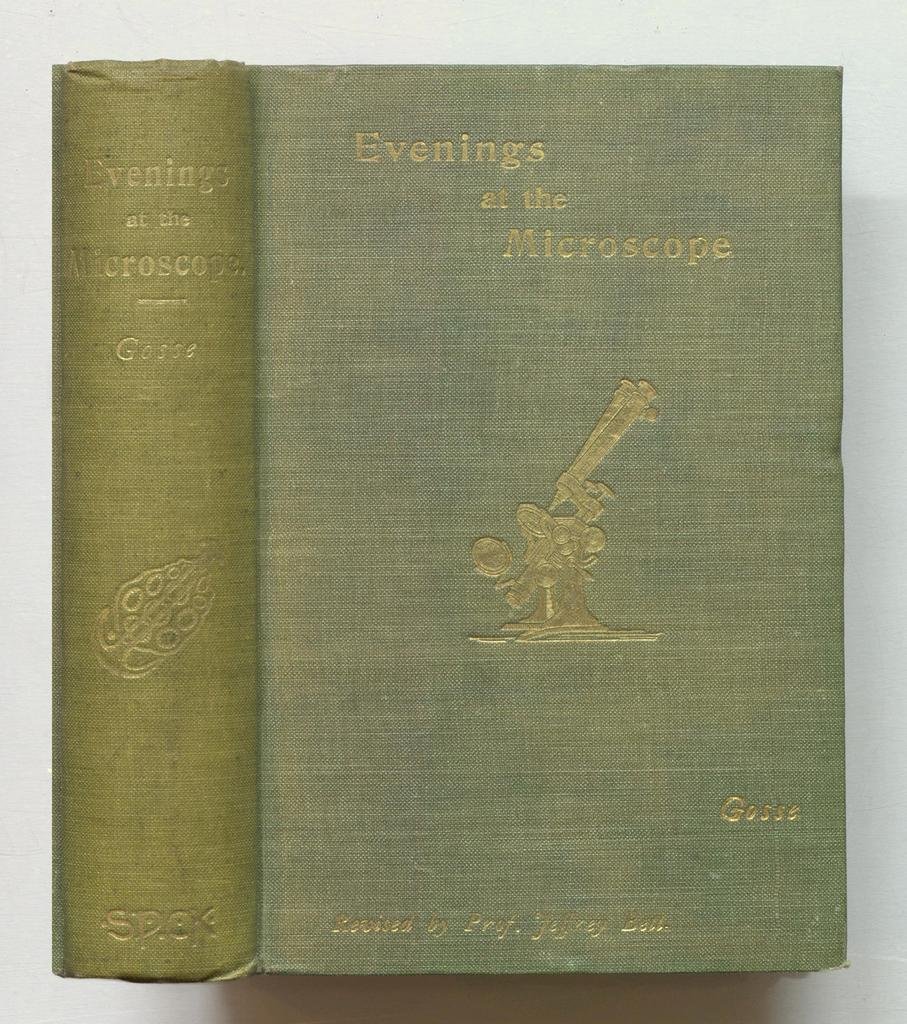<image>
Present a compact description of the photo's key features. An older book titled Evenings at the Microscope. 